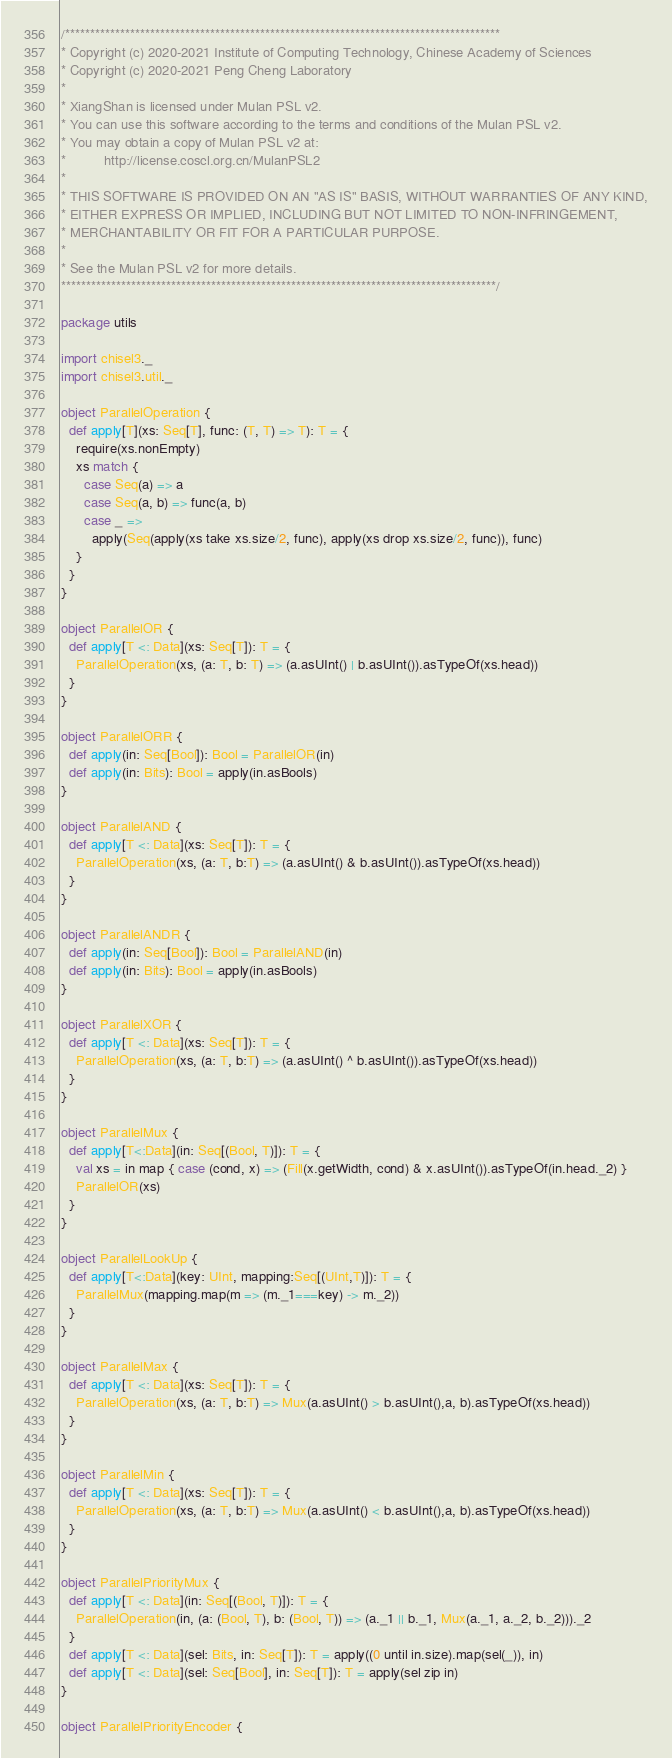Convert code to text. <code><loc_0><loc_0><loc_500><loc_500><_Scala_>/***************************************************************************************
* Copyright (c) 2020-2021 Institute of Computing Technology, Chinese Academy of Sciences
* Copyright (c) 2020-2021 Peng Cheng Laboratory
*
* XiangShan is licensed under Mulan PSL v2.
* You can use this software according to the terms and conditions of the Mulan PSL v2.
* You may obtain a copy of Mulan PSL v2 at:
*          http://license.coscl.org.cn/MulanPSL2
*
* THIS SOFTWARE IS PROVIDED ON AN "AS IS" BASIS, WITHOUT WARRANTIES OF ANY KIND,
* EITHER EXPRESS OR IMPLIED, INCLUDING BUT NOT LIMITED TO NON-INFRINGEMENT,
* MERCHANTABILITY OR FIT FOR A PARTICULAR PURPOSE.
*
* See the Mulan PSL v2 for more details.
***************************************************************************************/

package utils

import chisel3._
import chisel3.util._

object ParallelOperation {
  def apply[T](xs: Seq[T], func: (T, T) => T): T = {
    require(xs.nonEmpty)
    xs match {
      case Seq(a) => a
      case Seq(a, b) => func(a, b)
      case _ =>
        apply(Seq(apply(xs take xs.size/2, func), apply(xs drop xs.size/2, func)), func)
    }
  }
}

object ParallelOR {
  def apply[T <: Data](xs: Seq[T]): T = {
    ParallelOperation(xs, (a: T, b: T) => (a.asUInt() | b.asUInt()).asTypeOf(xs.head))
  }
}

object ParallelORR {
  def apply(in: Seq[Bool]): Bool = ParallelOR(in)
  def apply(in: Bits): Bool = apply(in.asBools)
}

object ParallelAND {
  def apply[T <: Data](xs: Seq[T]): T = {
    ParallelOperation(xs, (a: T, b:T) => (a.asUInt() & b.asUInt()).asTypeOf(xs.head))
  }
}

object ParallelANDR {
  def apply(in: Seq[Bool]): Bool = ParallelAND(in)
  def apply(in: Bits): Bool = apply(in.asBools)
}

object ParallelXOR {
  def apply[T <: Data](xs: Seq[T]): T = {
    ParallelOperation(xs, (a: T, b:T) => (a.asUInt() ^ b.asUInt()).asTypeOf(xs.head))
  }
}

object ParallelMux {
  def apply[T<:Data](in: Seq[(Bool, T)]): T = {
    val xs = in map { case (cond, x) => (Fill(x.getWidth, cond) & x.asUInt()).asTypeOf(in.head._2) }
    ParallelOR(xs)
  }
}

object ParallelLookUp {
  def apply[T<:Data](key: UInt, mapping:Seq[(UInt,T)]): T = {
    ParallelMux(mapping.map(m => (m._1===key) -> m._2))
  }
}

object ParallelMax {
  def apply[T <: Data](xs: Seq[T]): T = {
    ParallelOperation(xs, (a: T, b:T) => Mux(a.asUInt() > b.asUInt(),a, b).asTypeOf(xs.head))
  }
}

object ParallelMin {
  def apply[T <: Data](xs: Seq[T]): T = {
    ParallelOperation(xs, (a: T, b:T) => Mux(a.asUInt() < b.asUInt(),a, b).asTypeOf(xs.head))
  }
}

object ParallelPriorityMux {
  def apply[T <: Data](in: Seq[(Bool, T)]): T = {
    ParallelOperation(in, (a: (Bool, T), b: (Bool, T)) => (a._1 || b._1, Mux(a._1, a._2, b._2)))._2
  }
  def apply[T <: Data](sel: Bits, in: Seq[T]): T = apply((0 until in.size).map(sel(_)), in)
  def apply[T <: Data](sel: Seq[Bool], in: Seq[T]): T = apply(sel zip in)
}

object ParallelPriorityEncoder {</code> 